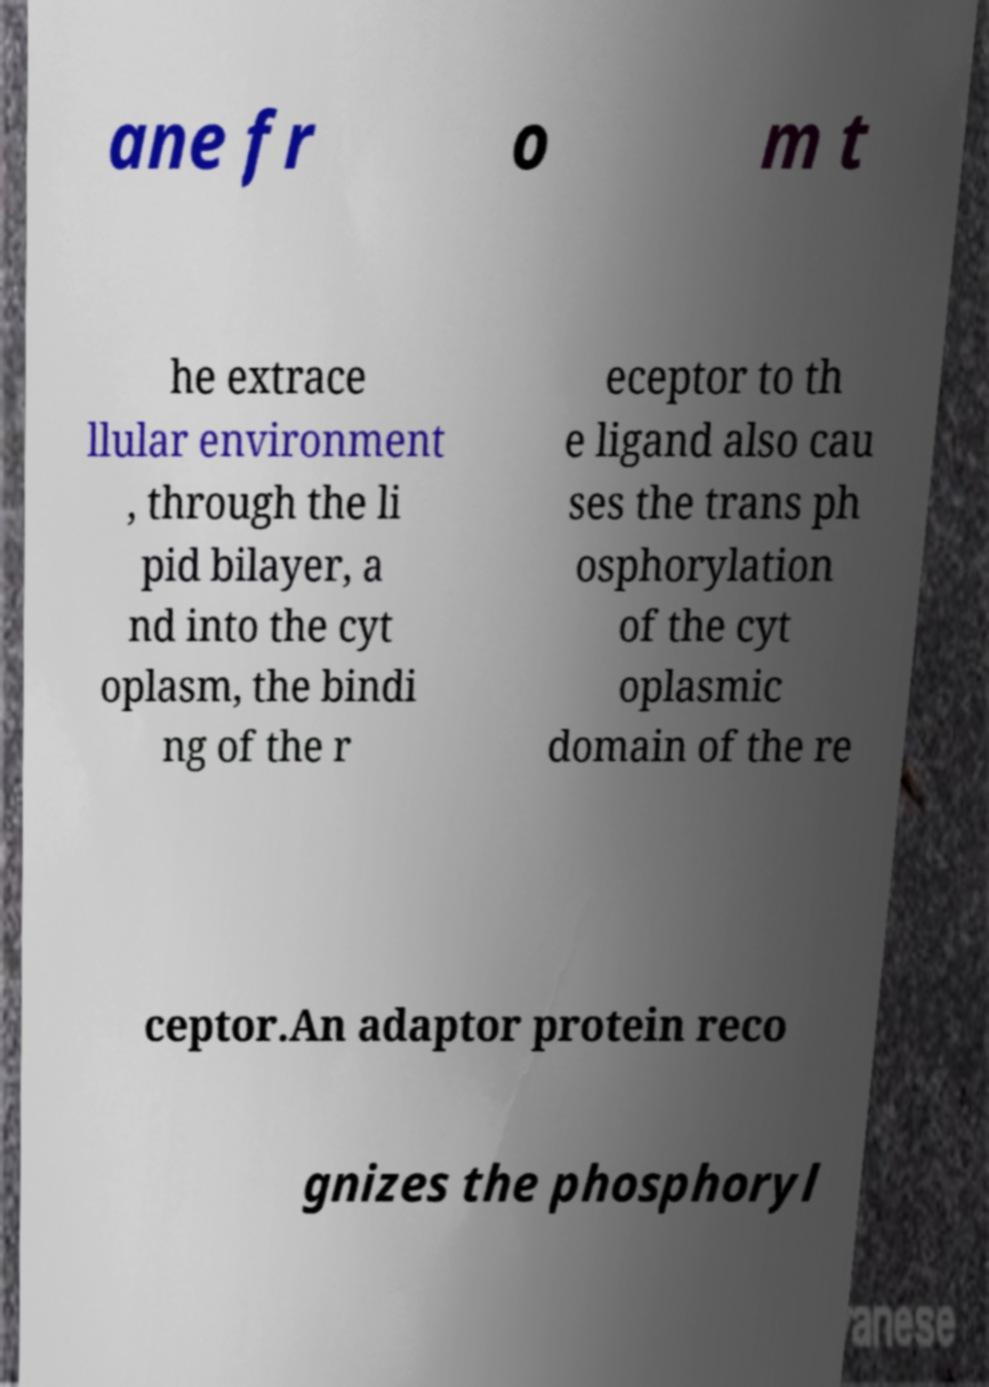Could you assist in decoding the text presented in this image and type it out clearly? ane fr o m t he extrace llular environment , through the li pid bilayer, a nd into the cyt oplasm, the bindi ng of the r eceptor to th e ligand also cau ses the trans ph osphorylation of the cyt oplasmic domain of the re ceptor.An adaptor protein reco gnizes the phosphoryl 